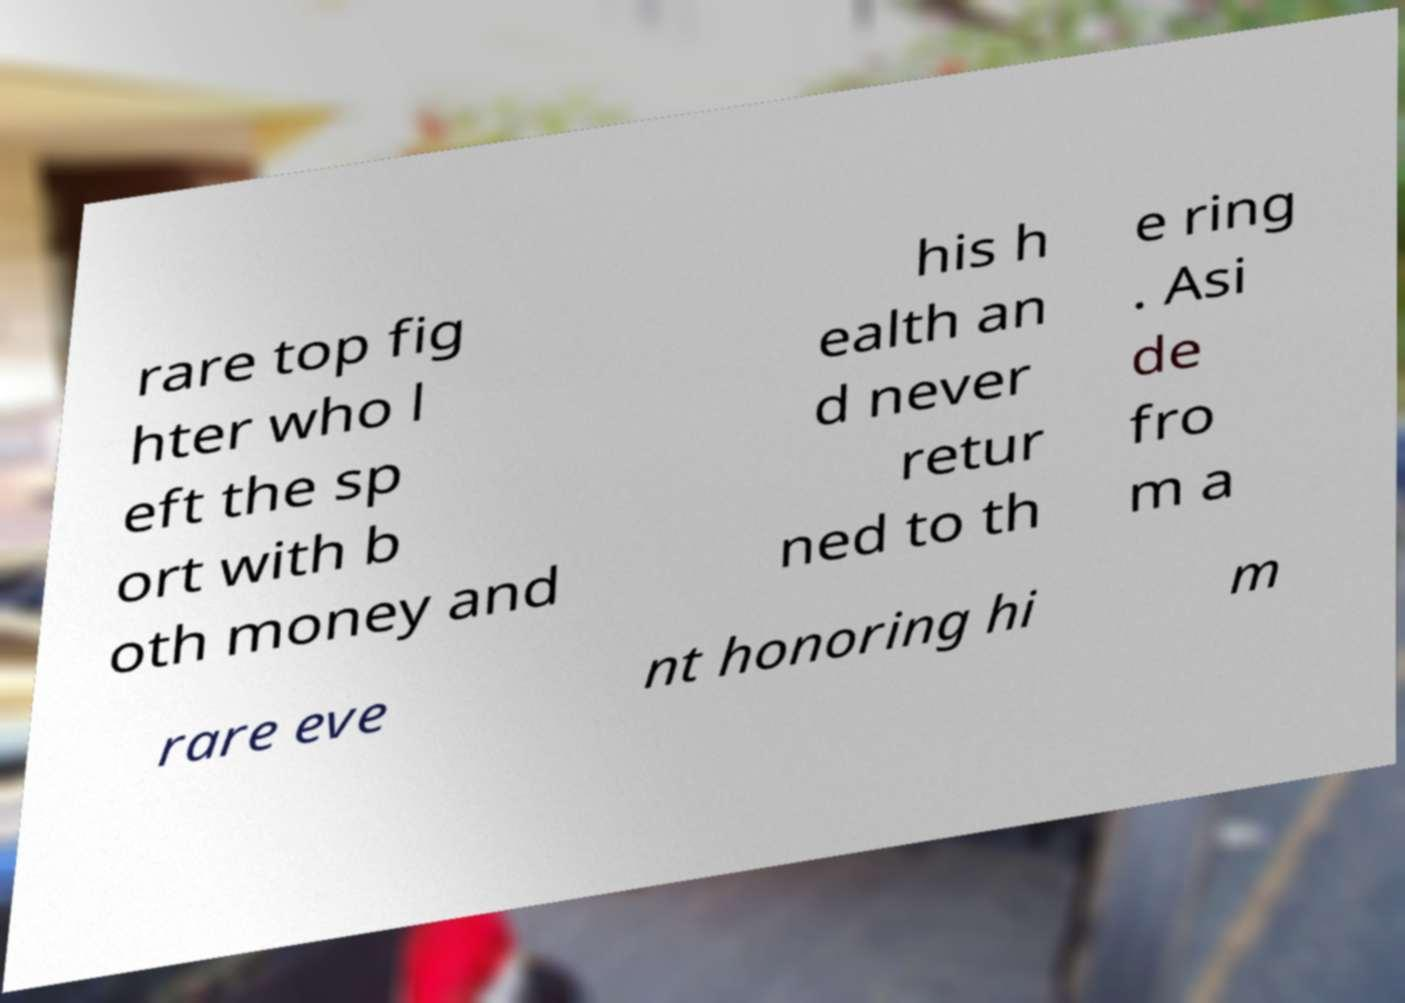There's text embedded in this image that I need extracted. Can you transcribe it verbatim? rare top fig hter who l eft the sp ort with b oth money and his h ealth an d never retur ned to th e ring . Asi de fro m a rare eve nt honoring hi m 